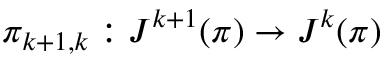Convert formula to latex. <formula><loc_0><loc_0><loc_500><loc_500>\pi _ { k + 1 , k } \colon J ^ { k + 1 } ( \pi ) \to J ^ { k } ( \pi )</formula> 